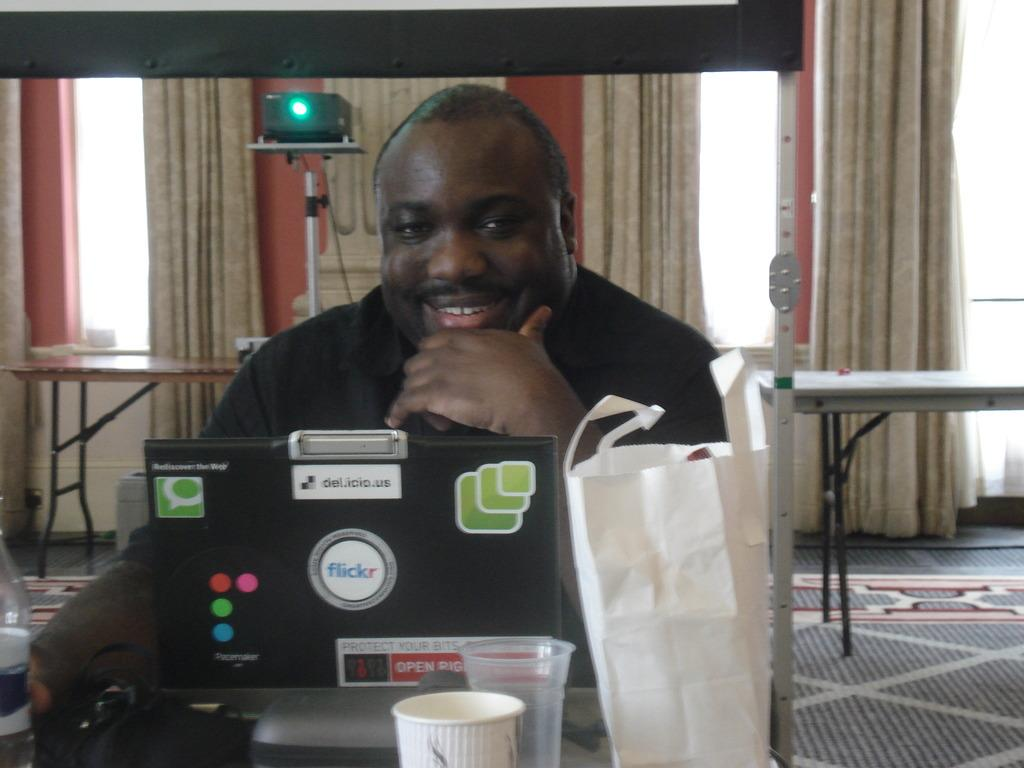What is the person in the image doing? There is a person sitting in the image. What electronic device is visible in the image? There is a laptop in the image. What type of containers can be seen in the image? There are cups in the image. What objects are in front of the person? There are other objects in front of the person. What architectural feature is visible in the image? There are windows in the image. What type of window treatment is present in the image? There are curtains in the image. What type of structure is visible in the image? There is a wall in the image. What type of furniture is present in the image? There are tables in the image. What type of market can be seen in the image? There is no market present in the image. What season is depicted in the image? The image does not depict a specific season, so it cannot be determined if it is winter or any other season. 